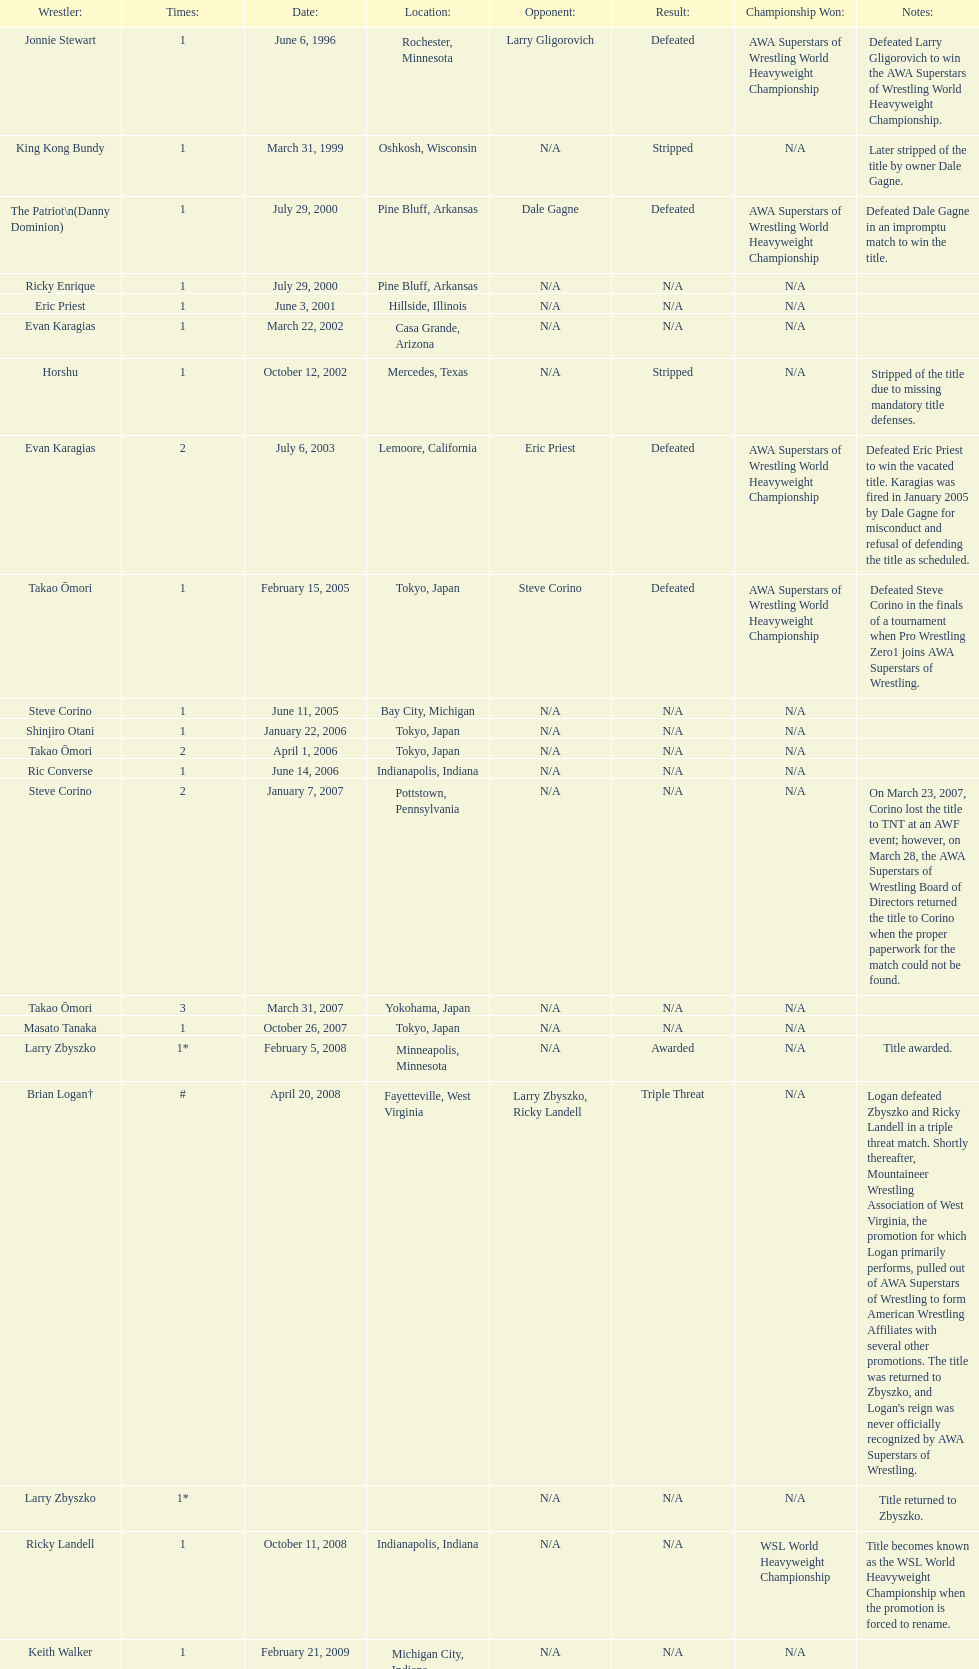Parse the table in full. {'header': ['Wrestler:', 'Times:', 'Date:', 'Location:', 'Opponent:', 'Result:', 'Championship Won:', 'Notes:'], 'rows': [['Jonnie Stewart', '1', 'June 6, 1996', 'Rochester, Minnesota', 'Larry Gligorovich', 'Defeated', 'AWA Superstars of Wrestling World Heavyweight Championship', 'Defeated Larry Gligorovich to win the AWA Superstars of Wrestling World Heavyweight Championship.'], ['King Kong Bundy', '1', 'March 31, 1999', 'Oshkosh, Wisconsin', 'N/A', 'Stripped', 'N/A', 'Later stripped of the title by owner Dale Gagne.'], ['The Patriot\\n(Danny Dominion)', '1', 'July 29, 2000', 'Pine Bluff, Arkansas', 'Dale Gagne', 'Defeated', 'AWA Superstars of Wrestling World Heavyweight Championship', 'Defeated Dale Gagne in an impromptu match to win the title.'], ['Ricky Enrique', '1', 'July 29, 2000', 'Pine Bluff, Arkansas', 'N/A', 'N/A', 'N/A', ''], ['Eric Priest', '1', 'June 3, 2001', 'Hillside, Illinois', 'N/A', 'N/A', 'N/A', ''], ['Evan Karagias', '1', 'March 22, 2002', 'Casa Grande, Arizona', 'N/A', 'N/A', 'N/A', ''], ['Horshu', '1', 'October 12, 2002', 'Mercedes, Texas', 'N/A', 'Stripped', 'N/A', 'Stripped of the title due to missing mandatory title defenses.'], ['Evan Karagias', '2', 'July 6, 2003', 'Lemoore, California', 'Eric Priest', 'Defeated', 'AWA Superstars of Wrestling World Heavyweight Championship', 'Defeated Eric Priest to win the vacated title. Karagias was fired in January 2005 by Dale Gagne for misconduct and refusal of defending the title as scheduled.'], ['Takao Ōmori', '1', 'February 15, 2005', 'Tokyo, Japan', 'Steve Corino', 'Defeated', 'AWA Superstars of Wrestling World Heavyweight Championship', 'Defeated Steve Corino in the finals of a tournament when Pro Wrestling Zero1 joins AWA Superstars of Wrestling.'], ['Steve Corino', '1', 'June 11, 2005', 'Bay City, Michigan', 'N/A', 'N/A', 'N/A', ''], ['Shinjiro Otani', '1', 'January 22, 2006', 'Tokyo, Japan', 'N/A', 'N/A', 'N/A', ''], ['Takao Ōmori', '2', 'April 1, 2006', 'Tokyo, Japan', 'N/A', 'N/A', 'N/A', ''], ['Ric Converse', '1', 'June 14, 2006', 'Indianapolis, Indiana', 'N/A', 'N/A', 'N/A', ''], ['Steve Corino', '2', 'January 7, 2007', 'Pottstown, Pennsylvania', 'N/A', 'N/A', 'N/A', 'On March 23, 2007, Corino lost the title to TNT at an AWF event; however, on March 28, the AWA Superstars of Wrestling Board of Directors returned the title to Corino when the proper paperwork for the match could not be found.'], ['Takao Ōmori', '3', 'March 31, 2007', 'Yokohama, Japan', 'N/A', 'N/A', 'N/A', ''], ['Masato Tanaka', '1', 'October 26, 2007', 'Tokyo, Japan', 'N/A', 'N/A', 'N/A', ''], ['Larry Zbyszko', '1*', 'February 5, 2008', 'Minneapolis, Minnesota', 'N/A', 'Awarded', 'N/A', 'Title awarded.'], ['Brian Logan†', '#', 'April 20, 2008', 'Fayetteville, West Virginia', 'Larry Zbyszko, Ricky Landell', 'Triple Threat', 'N/A', "Logan defeated Zbyszko and Ricky Landell in a triple threat match. Shortly thereafter, Mountaineer Wrestling Association of West Virginia, the promotion for which Logan primarily performs, pulled out of AWA Superstars of Wrestling to form American Wrestling Affiliates with several other promotions. The title was returned to Zbyszko, and Logan's reign was never officially recognized by AWA Superstars of Wrestling."], ['Larry Zbyszko', '1*', '', '', 'N/A', 'N/A', 'N/A', 'Title returned to Zbyszko.'], ['Ricky Landell', '1', 'October 11, 2008', 'Indianapolis, Indiana', 'N/A', 'N/A', 'WSL World Heavyweight Championship', 'Title becomes known as the WSL World Heavyweight Championship when the promotion is forced to rename.'], ['Keith Walker', '1', 'February 21, 2009', 'Michigan City, Indiana', 'N/A', 'N/A', 'N/A', ''], ['Jonnie Stewart', '2', 'June 9, 2012', 'Landover, Maryland', 'Keith Walker, Ricky Landell', 'Refused', 'AWA Superstars of Wrestling World Heavyweight Championship', "In a day referred to as The Saturday Night Massacre, in reference to President Nixon's firing of two Whitehouse attorneys general in one night; President Dale Gagne strips and fires Keith Walker when Walker refuses to defend the title against Ricky Landell, in an event in Landover, Maryland. When Landell is awarded the title, he refuses to accept and is too promptly fired by Gagne, who than awards the title to Jonnie Stewart."], ['The Honky Tonk Man', '1', 'August 18, 2012', 'Rockford, Illinois', 'Jonnie Stewart', 'Substitute', 'AWA Superstars of Wrestling World Heavyweight Championship', "The morning of the event, Jonnie Stewart's doctors declare him PUP (physically unable to perform) and WSL officials agree to let Mike Bally sub for Stewart."]]} How many different men held the wsl title before horshu won his first wsl title? 6. 